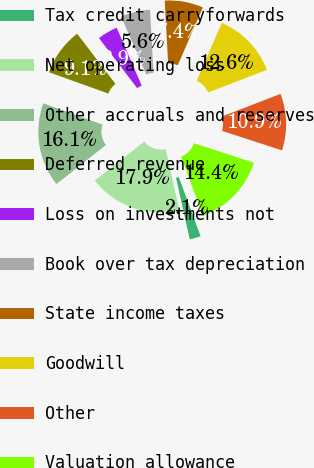<chart> <loc_0><loc_0><loc_500><loc_500><pie_chart><fcel>Tax credit carryforwards<fcel>Net operating loss<fcel>Other accruals and reserves<fcel>Deferred revenue<fcel>Loss on investments not<fcel>Book over tax depreciation<fcel>State income taxes<fcel>Goodwill<fcel>Other<fcel>Valuation allowance<nl><fcel>2.13%<fcel>17.87%<fcel>16.12%<fcel>9.13%<fcel>3.88%<fcel>5.63%<fcel>7.38%<fcel>12.62%<fcel>10.87%<fcel>14.37%<nl></chart> 